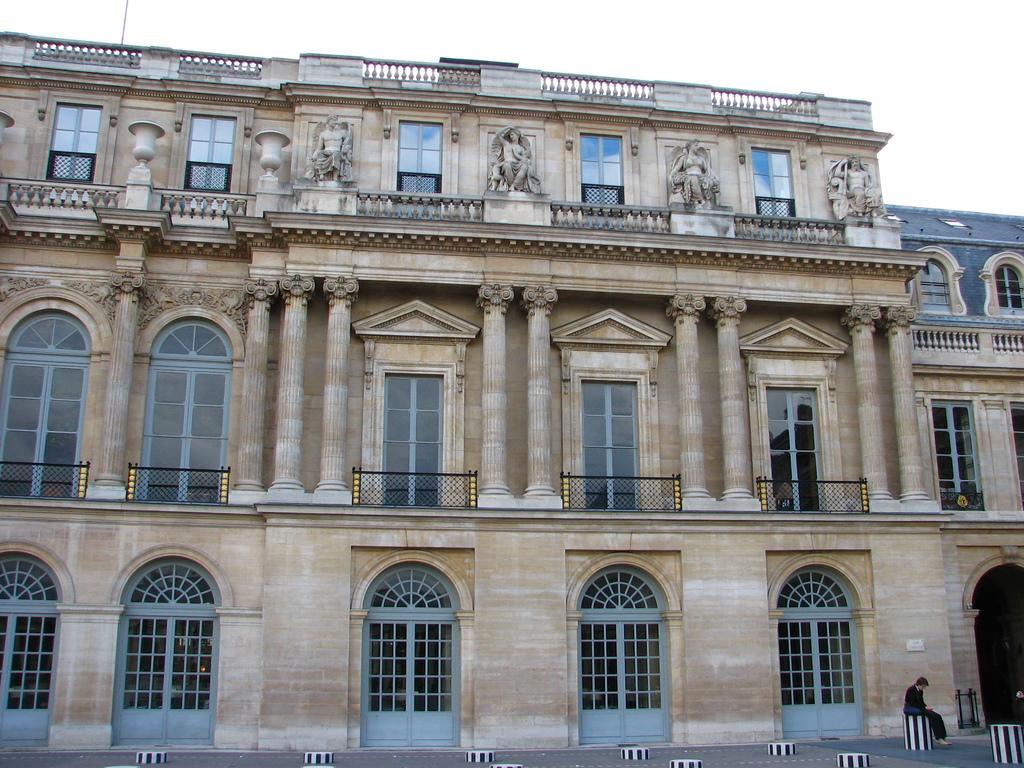Could you give a brief overview of what you see in this image? In this image we can see a building with windows, pillars and doors. We can also see a man sitting on a stool. On the backside we can see the sky. 